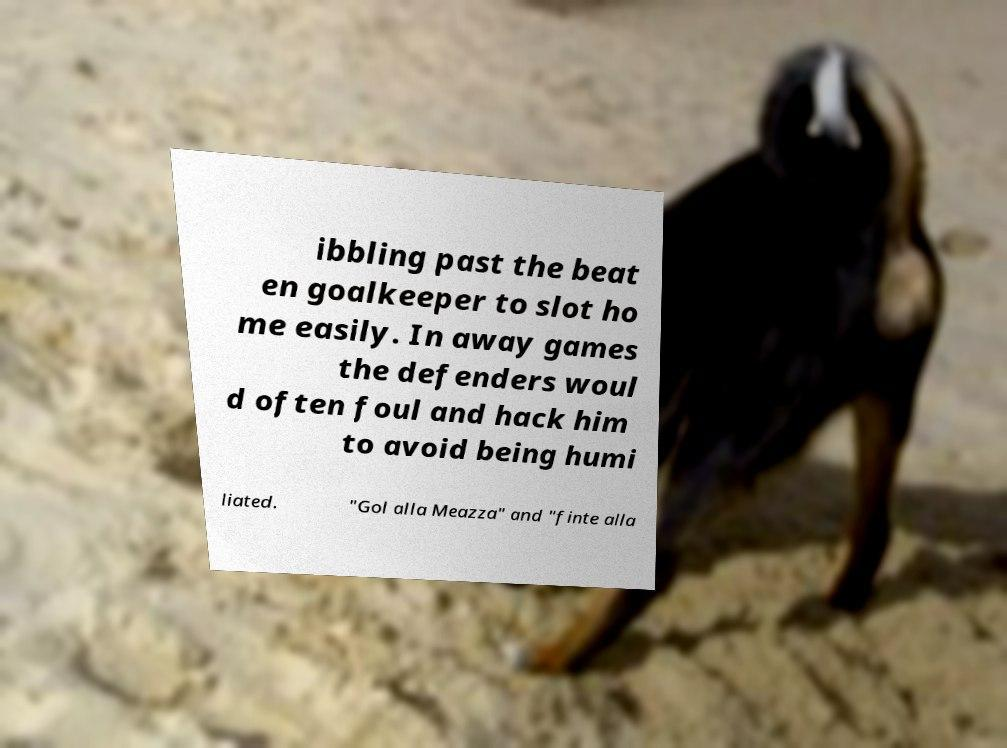For documentation purposes, I need the text within this image transcribed. Could you provide that? ibbling past the beat en goalkeeper to slot ho me easily. In away games the defenders woul d often foul and hack him to avoid being humi liated. "Gol alla Meazza" and "finte alla 